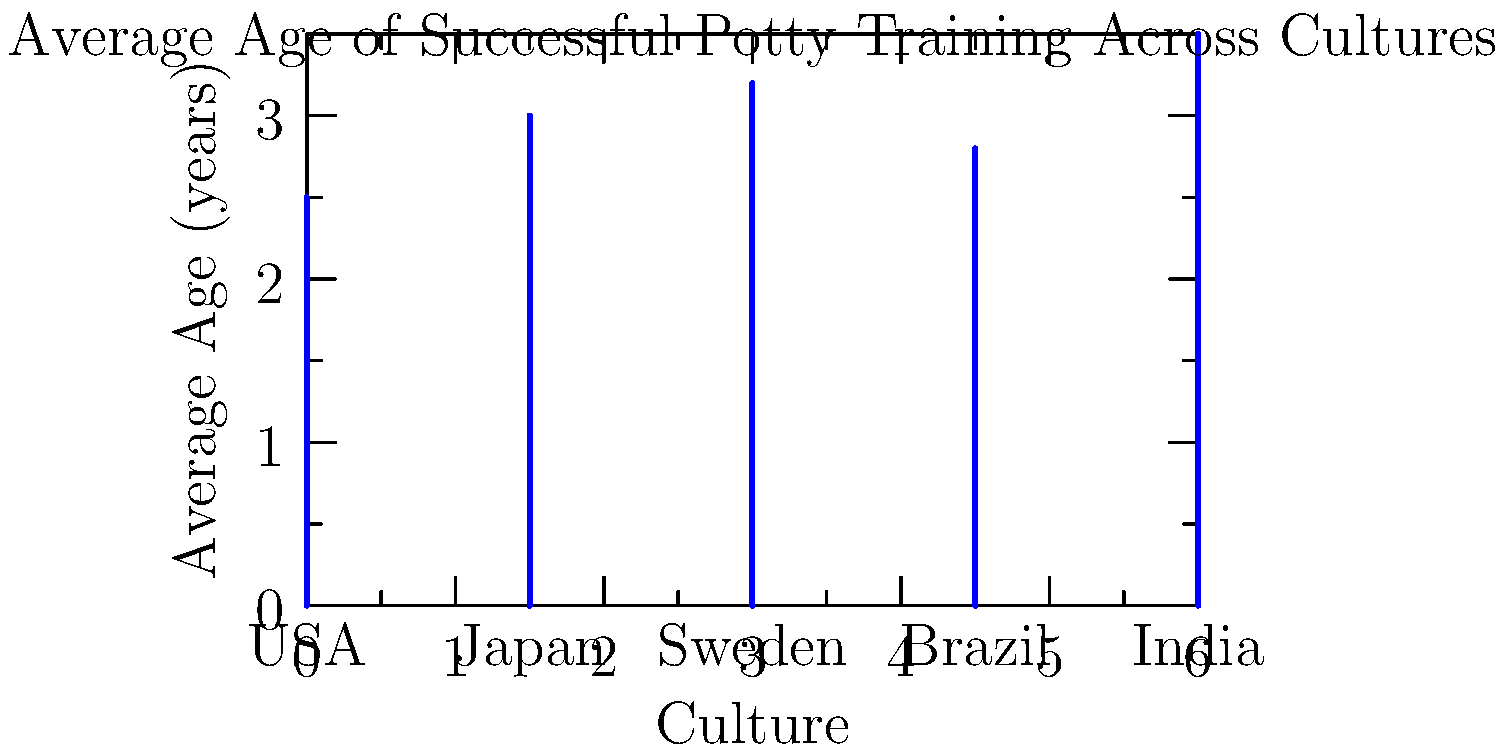As a patient and supportive mom focused on potty training, you come across this graph showing the average age of successful potty training across various cultures. What cultural factor might explain why India has the highest average age for successful potty training, and how could this information influence your approach with your own child? To answer this question, we need to analyze the graph and consider cultural factors that might influence potty training practices:

1. Observe the data: India has the highest average age (3.5 years) for successful potty training among the cultures shown.

2. Consider cultural factors:
   a. Diapering practices: India traditionally uses cloth diapers or practices elimination communication, which may delay structured potty training.
   b. Cultural attitudes: Some cultures may not rush potty training, believing children will naturally develop readiness.
   c. Climate: Warmer climates might influence clothing choices and hygiene practices.
   d. Family structure: Extended families might share caregiving responsibilities, potentially affecting consistency in training approaches.

3. Analyze the impact on personal approach:
   a. Recognize that there's a range of "normal" ages for potty training success across cultures.
   b. Consider adopting a more relaxed timeline, focusing on your child's individual readiness rather than arbitrary age milestones.
   c. Explore alternative methods, such as elimination communication or gradual transition approaches.
   d. Emphasize patience and support, understanding that later potty training doesn't indicate a problem.

4. Develop a culturally informed strategy:
   a. Research and potentially incorporate elements from various cultural approaches.
   b. Adapt your expectations based on this broader cultural context.
   c. Focus on creating a positive, stress-free environment for potty training, regardless of age.
Answer: Cultural factors like traditional diapering practices and relaxed attitudes towards training timelines in India may explain the higher average age. This information suggests adopting a patient, child-led approach to potty training, focusing on individual readiness rather than strict age-based goals. 